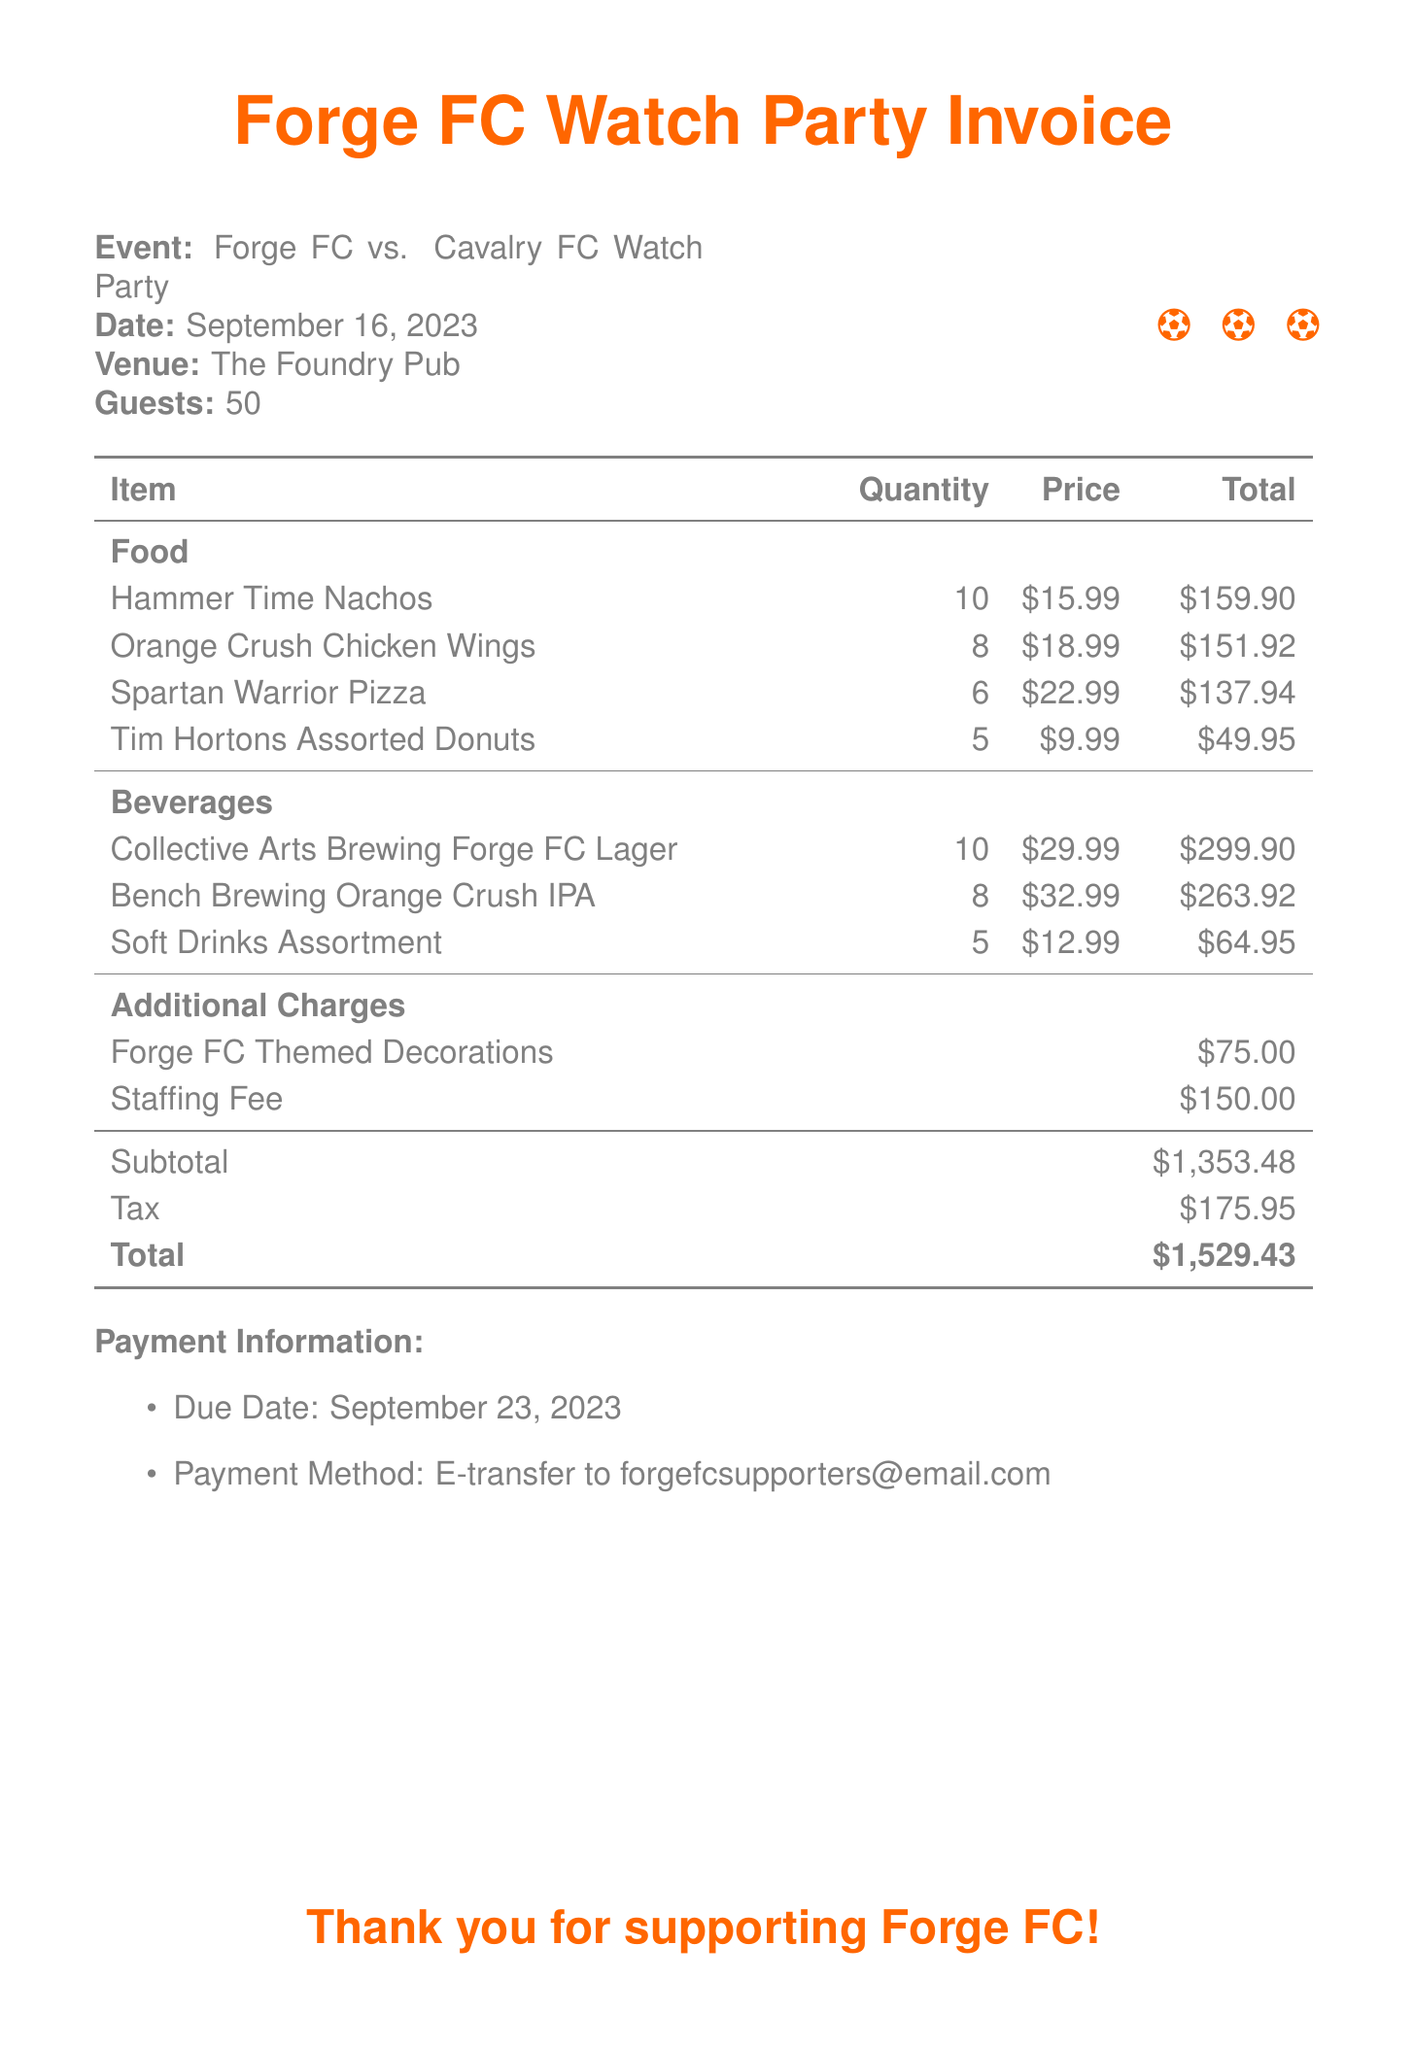what is the date of the event? The date of the event is explicitly mentioned in the document as September 16, 2023.
Answer: September 16, 2023 how many guests were there? The number of guests at the event is stated as 50 in the document.
Answer: 50 what is the total cost of food? To find the total cost of food, we add the total costs for each food item listed. The total food cost is $159.90 + $151.92 + $137.94 + $49.95 = $499.71.
Answer: $499.71 what is the subtotal amount? The subtotal amount is provided specifically in the document as $1,353.48.
Answer: $1,353.48 how many types of beverages were listed? The document lists three different types of beverages in the beverage section.
Answer: 3 what is the total invoice amount? The total invoice amount is clearly mentioned at the bottom of the document as \$1,529.43.
Answer: $1,529.43 what is the due date for payment? The due date for payment is specified in the payment information section as September 23, 2023.
Answer: September 23, 2023 what are the additional charges listed? The document includes two additional charges: Forge FC Themed Decorations and Staffing Fee, with a total of $225.00.
Answer: $225.00 what is the payment method? The payment method for the invoice is stated in the payment information section as E-transfer.
Answer: E-transfer 